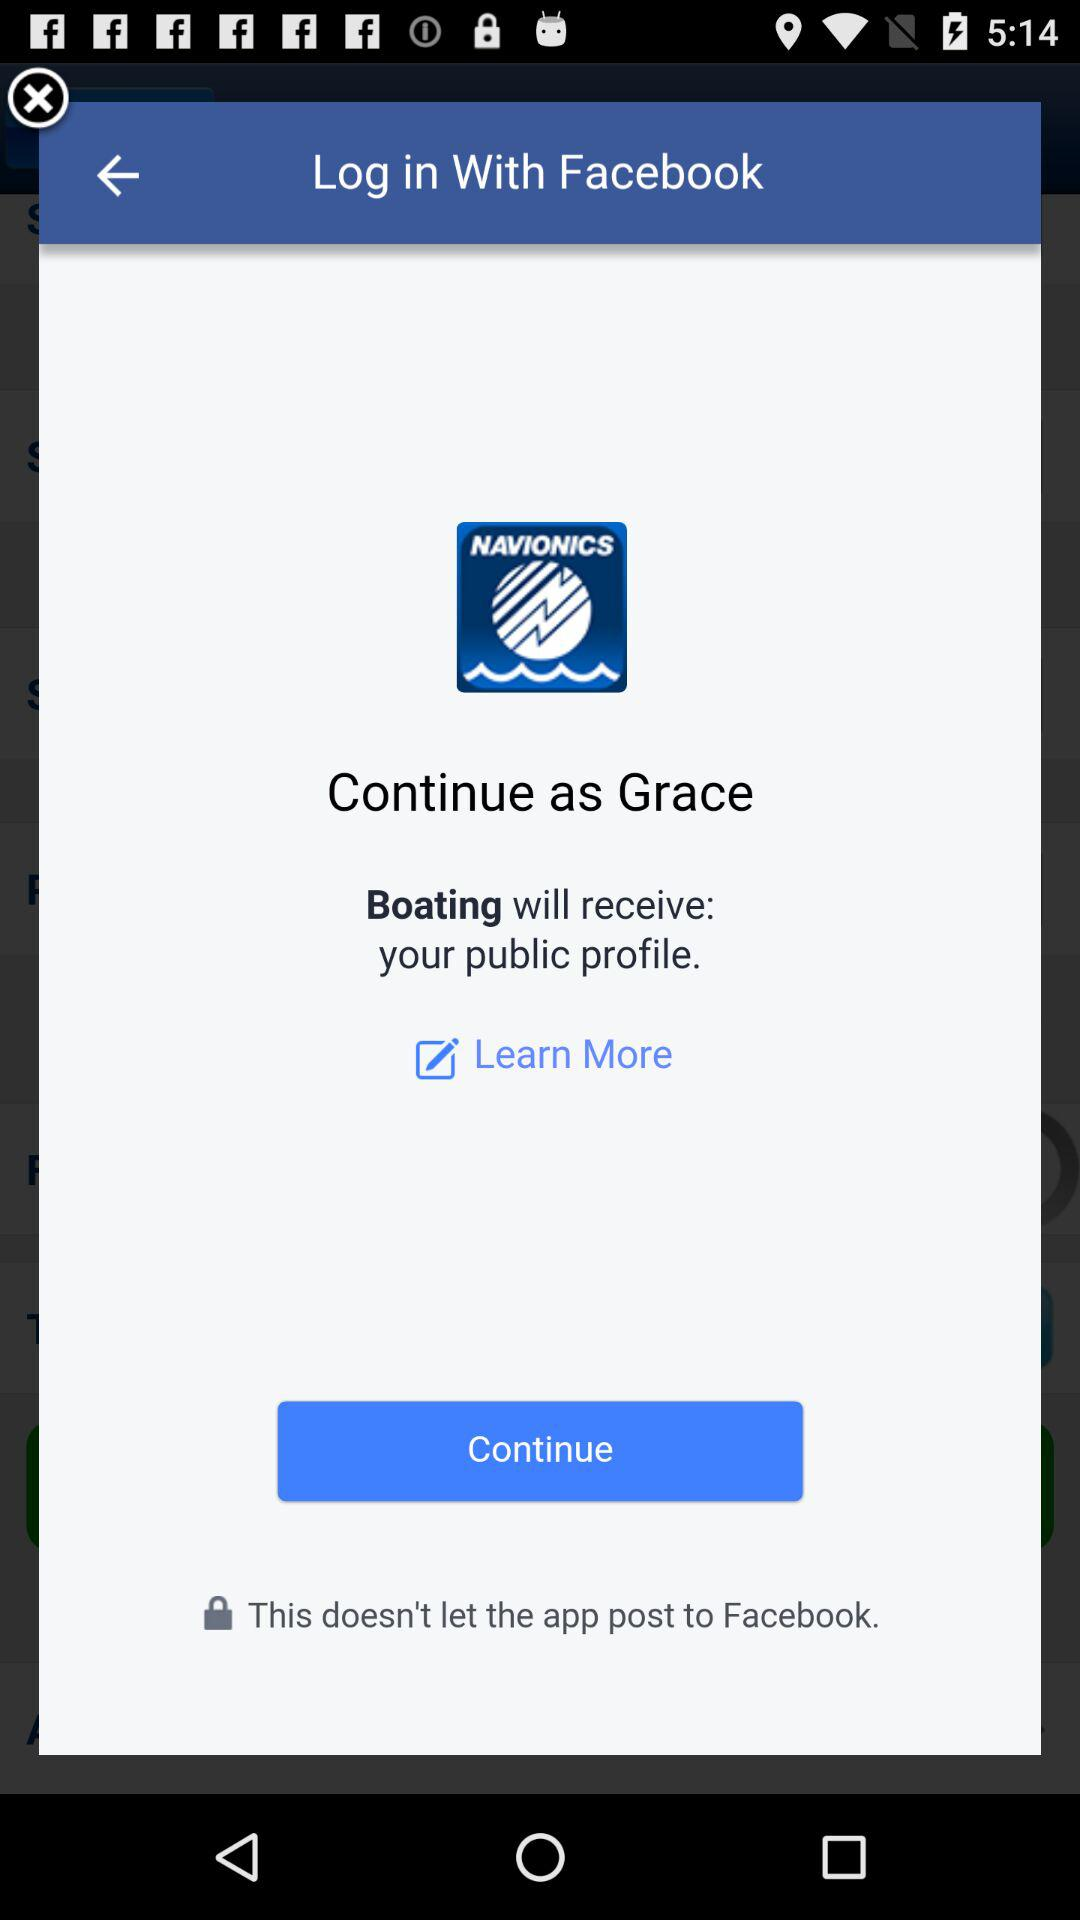What application is asking for permission? The application asking for permission is "Boating". 